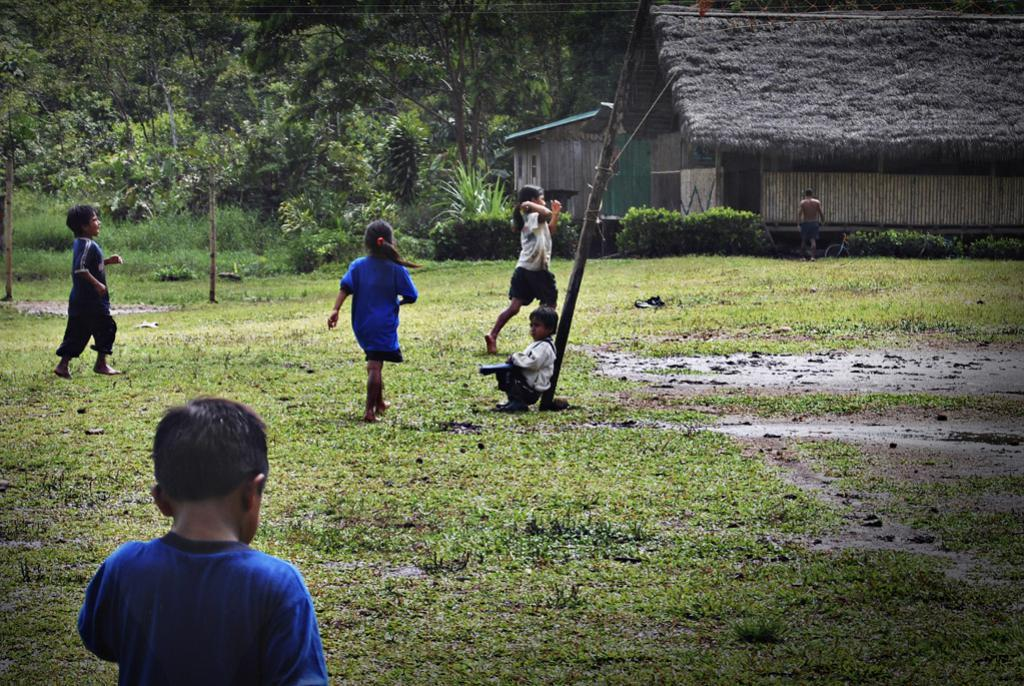How many children are in the image? There are many children in the image. What are the children doing in the image? Some children are walking, and one is sitting. What type of house can be seen in the image? There is a house made of wood in the image. What is the pole in the image used for? The purpose of the pole in the image is not specified, but it could be used for various purposes such as supporting a structure or hanging items. What type of terrain is visible in the image? Grass and mud are visible in the image, suggesting a grassy and potentially wet or damp area. How many trees are in the image? There are many trees in the image. What type of desk is visible in the image? There is no desk present in the image. What emotion can be seen on the children's faces in the image? The emotion of the children cannot be determined from the image, as their faces are not clearly visible. 